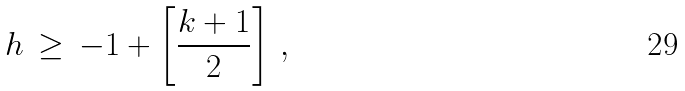<formula> <loc_0><loc_0><loc_500><loc_500>h \, \geq \, - 1 + \left [ \frac { k + 1 } { 2 } \right ] \, ,</formula> 